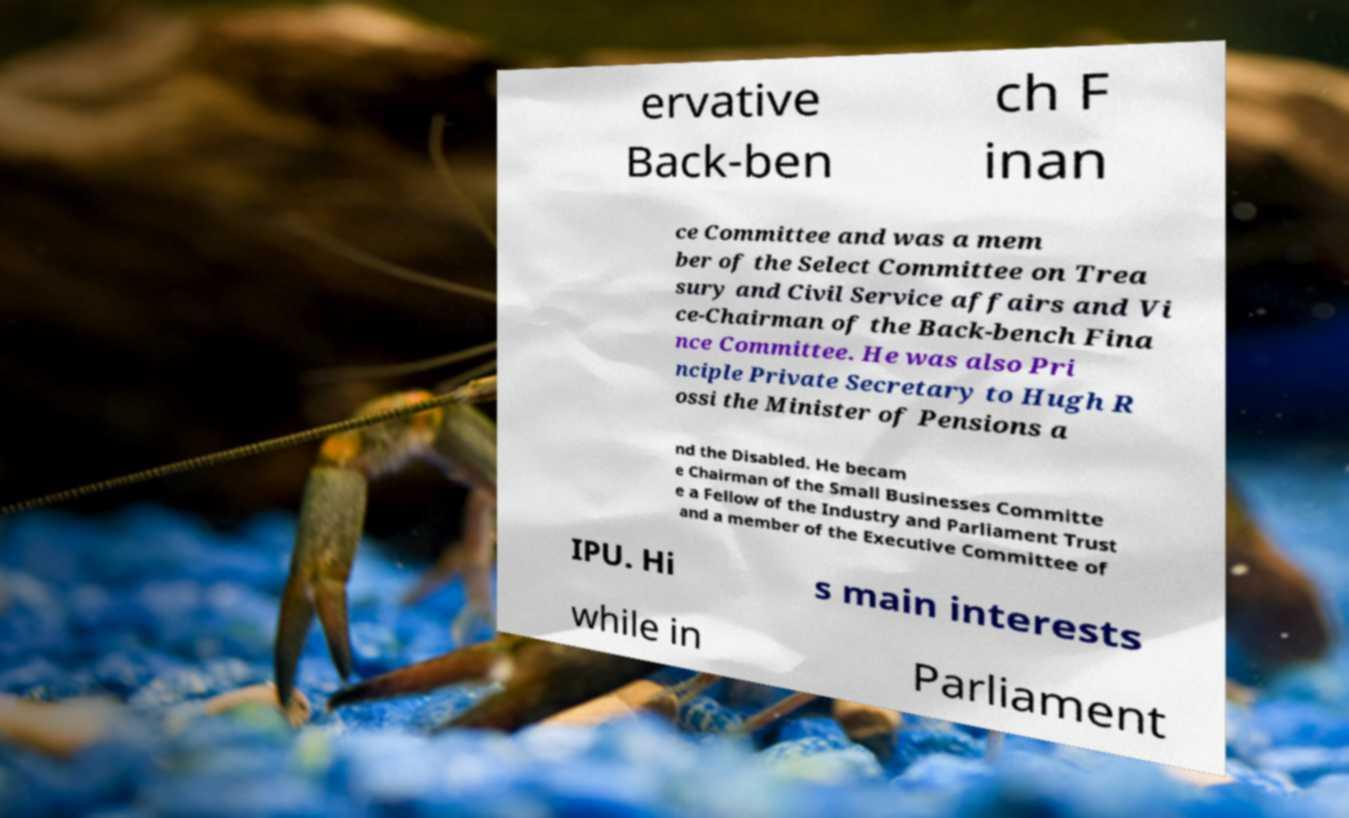Please read and relay the text visible in this image. What does it say? ervative Back-ben ch F inan ce Committee and was a mem ber of the Select Committee on Trea sury and Civil Service affairs and Vi ce-Chairman of the Back-bench Fina nce Committee. He was also Pri nciple Private Secretary to Hugh R ossi the Minister of Pensions a nd the Disabled. He becam e Chairman of the Small Businesses Committe e a Fellow of the Industry and Parliament Trust and a member of the Executive Committee of IPU. Hi s main interests while in Parliament 